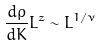<formula> <loc_0><loc_0><loc_500><loc_500>\frac { d \rho } { d K } L ^ { z } \sim L ^ { 1 / \nu }</formula> 